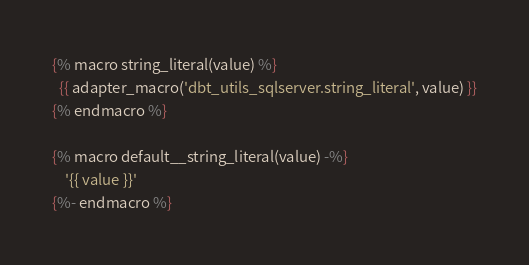Convert code to text. <code><loc_0><loc_0><loc_500><loc_500><_SQL_>
{% macro string_literal(value) %}
  {{ adapter_macro('dbt_utils_sqlserver.string_literal', value) }}
{% endmacro %}

{% macro default__string_literal(value) -%}
    '{{ value }}'
{%- endmacro %}
</code> 